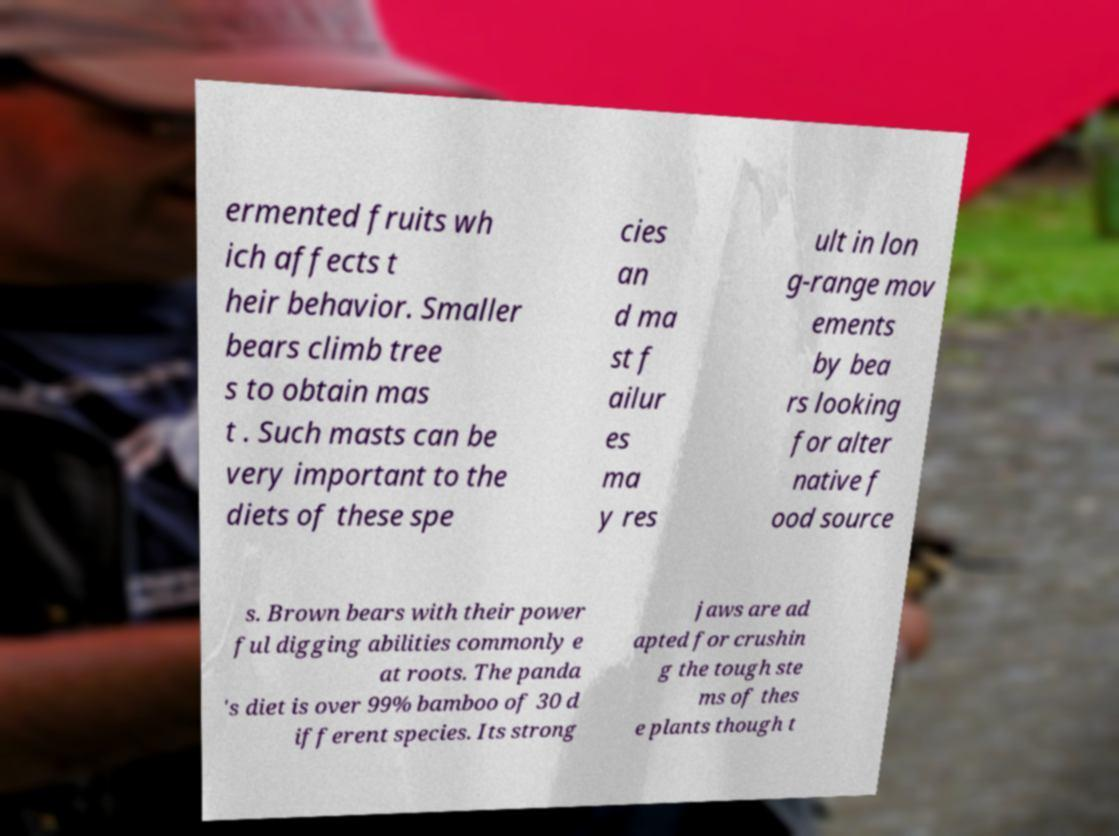Can you read and provide the text displayed in the image?This photo seems to have some interesting text. Can you extract and type it out for me? ermented fruits wh ich affects t heir behavior. Smaller bears climb tree s to obtain mas t . Such masts can be very important to the diets of these spe cies an d ma st f ailur es ma y res ult in lon g-range mov ements by bea rs looking for alter native f ood source s. Brown bears with their power ful digging abilities commonly e at roots. The panda 's diet is over 99% bamboo of 30 d ifferent species. Its strong jaws are ad apted for crushin g the tough ste ms of thes e plants though t 